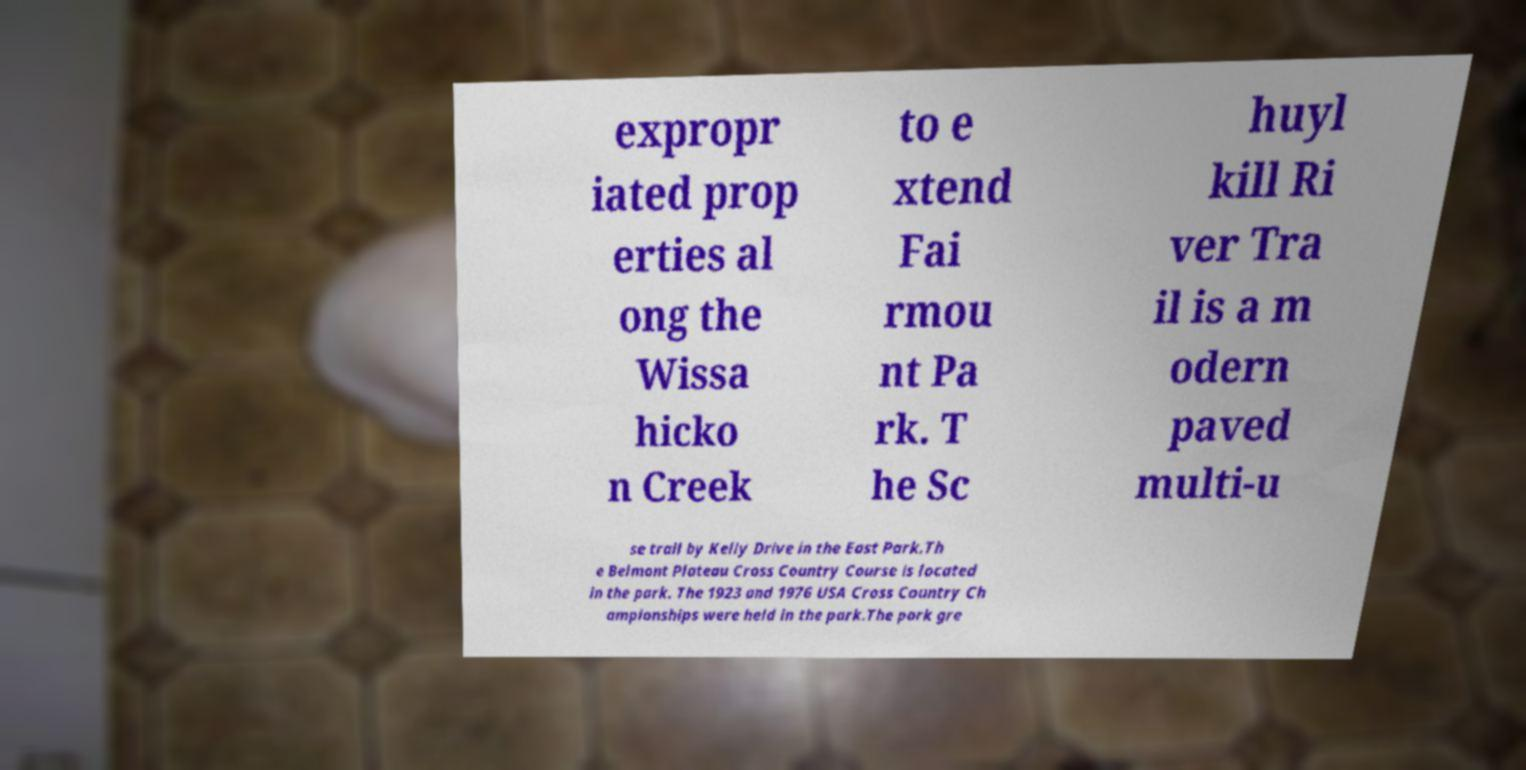I need the written content from this picture converted into text. Can you do that? expropr iated prop erties al ong the Wissa hicko n Creek to e xtend Fai rmou nt Pa rk. T he Sc huyl kill Ri ver Tra il is a m odern paved multi-u se trail by Kelly Drive in the East Park.Th e Belmont Plateau Cross Country Course is located in the park. The 1923 and 1976 USA Cross Country Ch ampionships were held in the park.The park gre 